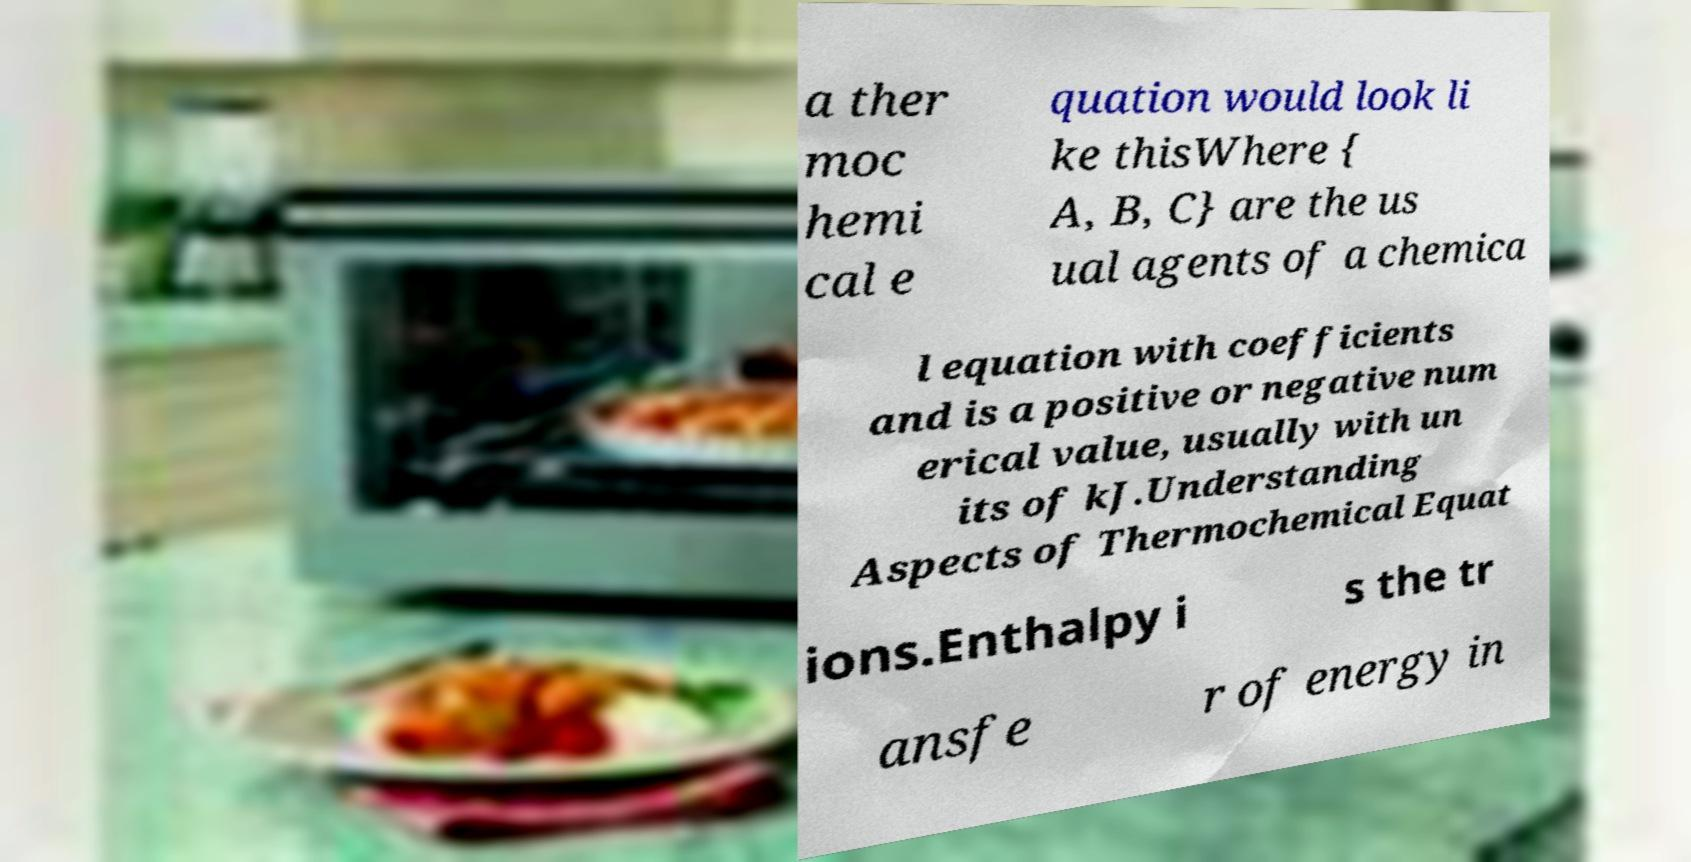Can you accurately transcribe the text from the provided image for me? a ther moc hemi cal e quation would look li ke thisWhere { A, B, C} are the us ual agents of a chemica l equation with coefficients and is a positive or negative num erical value, usually with un its of kJ.Understanding Aspects of Thermochemical Equat ions.Enthalpy i s the tr ansfe r of energy in 